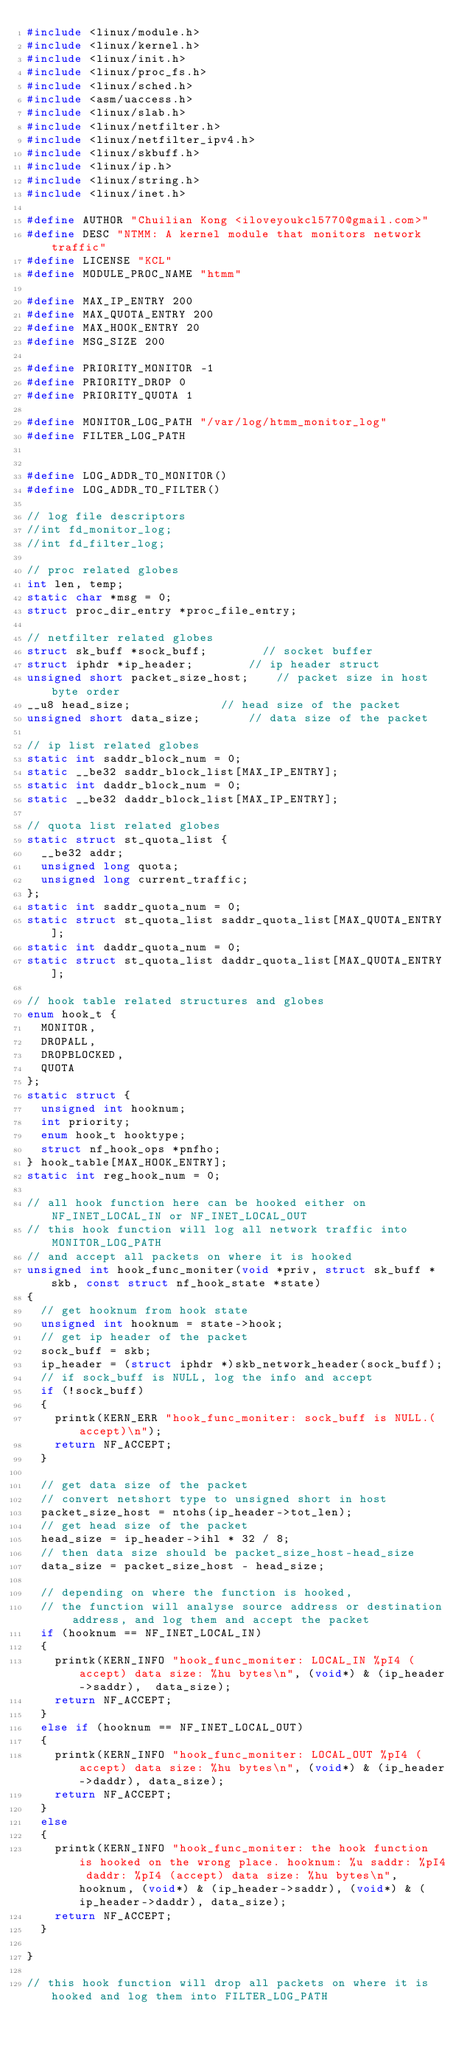Convert code to text. <code><loc_0><loc_0><loc_500><loc_500><_C_>#include <linux/module.h>
#include <linux/kernel.h>
#include <linux/init.h>
#include <linux/proc_fs.h>
#include <linux/sched.h>
#include <asm/uaccess.h>
#include <linux/slab.h>
#include <linux/netfilter.h>
#include <linux/netfilter_ipv4.h>
#include <linux/skbuff.h>
#include <linux/ip.h>
#include <linux/string.h>
#include <linux/inet.h>

#define AUTHOR "Chuilian Kong <iloveyoukcl5770@gmail.com>"
#define DESC "NTMM: A kernel module that monitors network traffic"
#define LICENSE "KCL"
#define MODULE_PROC_NAME "htmm"

#define MAX_IP_ENTRY 200
#define MAX_QUOTA_ENTRY 200
#define MAX_HOOK_ENTRY 20
#define MSG_SIZE 200

#define PRIORITY_MONITOR -1
#define PRIORITY_DROP 0
#define PRIORITY_QUOTA 1

#define MONITOR_LOG_PATH "/var/log/htmm_monitor_log"
#define FILTER_LOG_PATH


#define LOG_ADDR_TO_MONITOR()
#define LOG_ADDR_TO_FILTER()

// log file descriptors
//int fd_monitor_log;
//int fd_filter_log;

// proc related globes
int len, temp;
static char *msg = 0;
struct proc_dir_entry *proc_file_entry;

// netfilter related globes
struct sk_buff *sock_buff;				// socket buffer
struct iphdr *ip_header;				// ip header struct
unsigned short packet_size_host;		// packet size in host byte order
__u8 head_size; 						// head size of the packet
unsigned short data_size;				// data size of the packet

// ip list related globes
static int saddr_block_num = 0;
static __be32 saddr_block_list[MAX_IP_ENTRY];
static int daddr_block_num = 0;
static __be32 daddr_block_list[MAX_IP_ENTRY];

// quota list related globes
static struct st_quota_list {
	__be32 addr;
	unsigned long quota;
	unsigned long current_traffic;
};
static int saddr_quota_num = 0;
static struct st_quota_list saddr_quota_list[MAX_QUOTA_ENTRY];
static int daddr_quota_num = 0;
static struct st_quota_list daddr_quota_list[MAX_QUOTA_ENTRY];

// hook table related structures and globes
enum hook_t {
	MONITOR,
	DROPALL,
	DROPBLOCKED,
	QUOTA
};
static struct {
	unsigned int hooknum;
	int priority;
	enum hook_t hooktype;
	struct nf_hook_ops *pnfho;
} hook_table[MAX_HOOK_ENTRY];
static int reg_hook_num = 0;

// all hook function here can be hooked either on NF_INET_LOCAL_IN or NF_INET_LOCAL_OUT
// this hook function will log all network traffic into MONITOR_LOG_PATH
// and accept all packets on where it is hooked
unsigned int hook_func_moniter(void *priv, struct sk_buff *skb, const struct nf_hook_state *state)
{
	// get hooknum from hook state
	unsigned int hooknum = state->hook;
	// get ip header of the packet
	sock_buff = skb;
	ip_header = (struct iphdr *)skb_network_header(sock_buff);
	// if sock_buff is NULL, log the info and accept
	if (!sock_buff)
	{
		printk(KERN_ERR "hook_func_moniter: sock_buff is NULL.(accept)\n");
		return NF_ACCEPT;
	}

	// get data size of the packet
	// convert netshort type to unsigned short in host
	packet_size_host = ntohs(ip_header->tot_len);
	// get head size of the packet
	head_size = ip_header->ihl * 32 / 8;
	// then data size should be packet_size_host-head_size
	data_size = packet_size_host - head_size;

	// depending on where the function is hooked,
	// the function will analyse source address or destination address, and log them and accept the packet
	if (hooknum == NF_INET_LOCAL_IN)
	{
		printk(KERN_INFO "hook_func_moniter: LOCAL_IN %pI4 (accept) data size: %hu bytes\n", (void*) & (ip_header->saddr),  data_size);
		return NF_ACCEPT;
	}
	else if (hooknum == NF_INET_LOCAL_OUT)
	{
		printk(KERN_INFO "hook_func_moniter: LOCAL_OUT %pI4 (accept) data size: %hu bytes\n", (void*) & (ip_header->daddr), data_size);
		return NF_ACCEPT;
	}
	else
	{
		printk(KERN_INFO "hook_func_moniter: the hook function is hooked on the wrong place. hooknum: %u saddr: %pI4 daddr: %pI4 (accept) data size: %hu bytes\n", hooknum, (void*) & (ip_header->saddr), (void*) & (ip_header->daddr), data_size);
		return NF_ACCEPT;
	}

}

// this hook function will drop all packets on where it is hooked and log them into FILTER_LOG_PATH</code> 